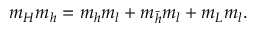<formula> <loc_0><loc_0><loc_500><loc_500>m _ { H } m _ { h } = m _ { h } m _ { l } + m _ { { \bar { h } } } m _ { l } + m _ { L } m _ { l } .</formula> 